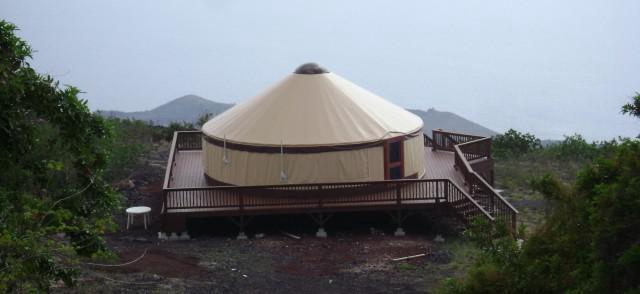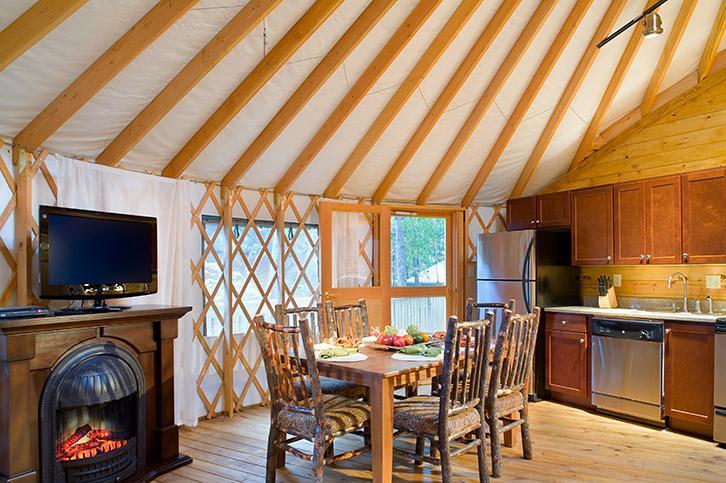The first image is the image on the left, the second image is the image on the right. Analyze the images presented: Is the assertion "An interior and an exterior image of a round house are shown." valid? Answer yes or no. Yes. 